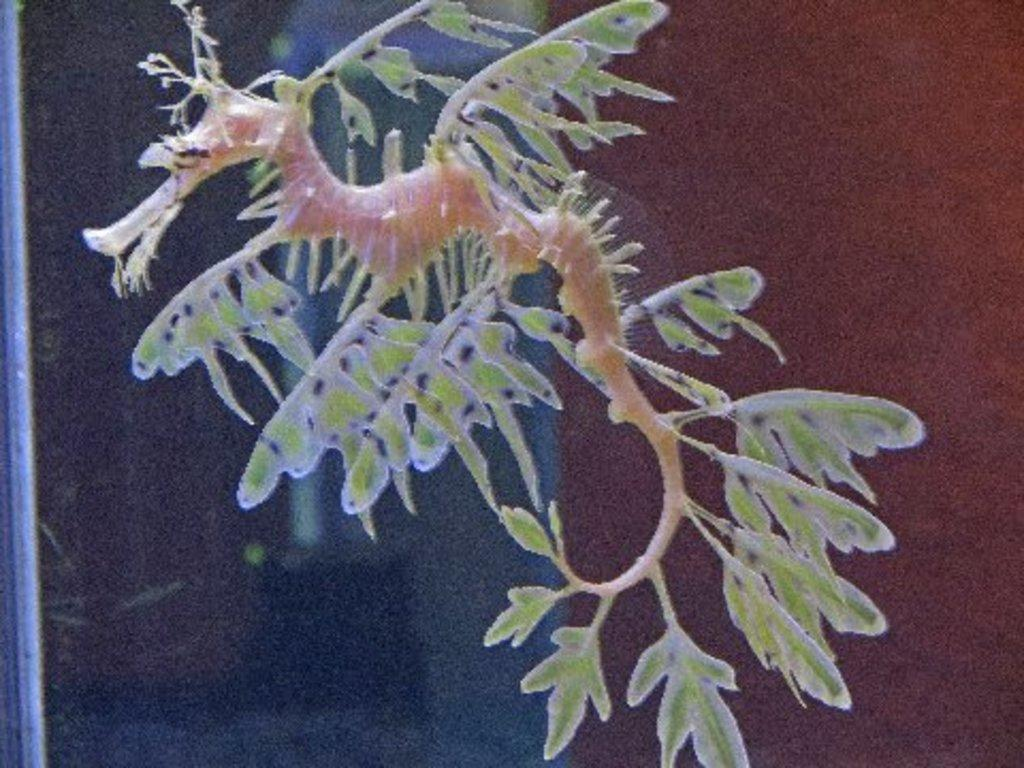What type of animal is in the image? The type of animal cannot be determined from the provided facts. What object is visible in the image besides the animal? There is a glass in the image. Can you describe the background of the image? The background of the image is blurry. What type of potato is being used as a whistle in the image? There is no potato or whistle present in the image. 